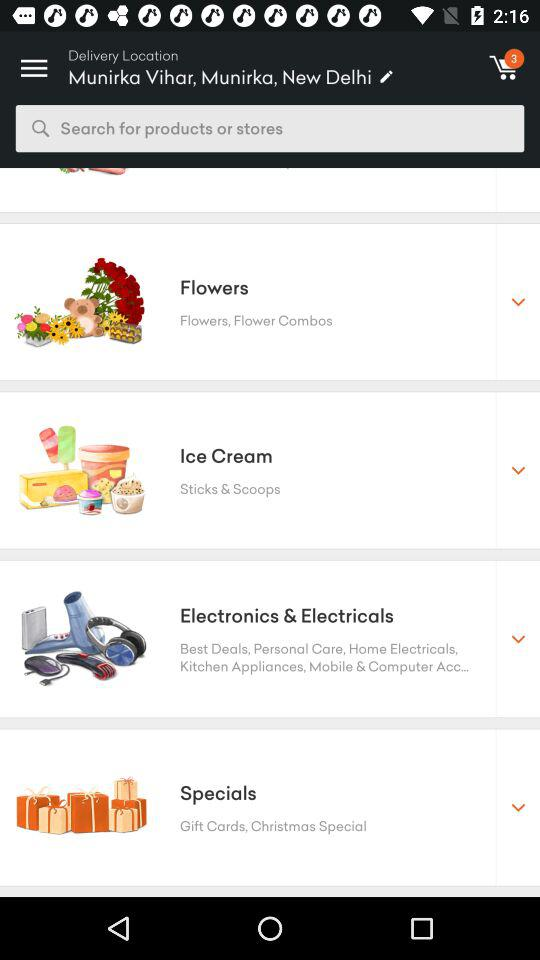Which place is selected? The selected place is Munirka Vihar, Munirka, New Delhi. 